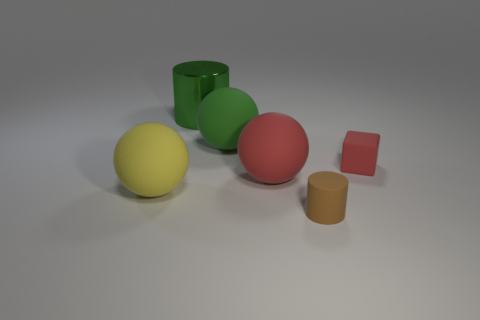Subtract all green matte balls. How many balls are left? 2 Add 2 green matte spheres. How many objects exist? 8 Subtract all blocks. How many objects are left? 5 Add 2 big yellow objects. How many big yellow objects are left? 3 Add 1 cubes. How many cubes exist? 2 Subtract 0 blue cubes. How many objects are left? 6 Subtract all yellow spheres. Subtract all tiny rubber cylinders. How many objects are left? 4 